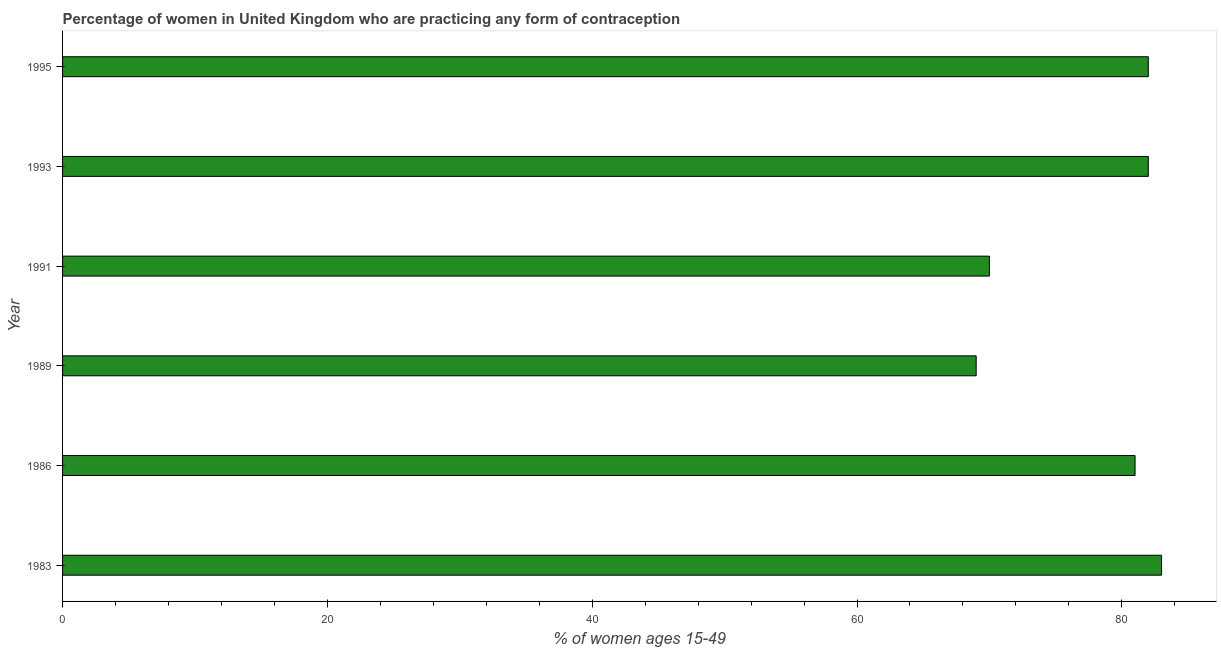Does the graph contain any zero values?
Offer a very short reply. No. What is the title of the graph?
Offer a terse response. Percentage of women in United Kingdom who are practicing any form of contraception. What is the label or title of the X-axis?
Offer a terse response. % of women ages 15-49. What is the label or title of the Y-axis?
Offer a terse response. Year. What is the contraceptive prevalence in 1991?
Give a very brief answer. 70. Across all years, what is the maximum contraceptive prevalence?
Your response must be concise. 83. Across all years, what is the minimum contraceptive prevalence?
Offer a very short reply. 69. In which year was the contraceptive prevalence maximum?
Make the answer very short. 1983. What is the sum of the contraceptive prevalence?
Your answer should be compact. 467. What is the median contraceptive prevalence?
Your answer should be compact. 81.5. What is the ratio of the contraceptive prevalence in 1986 to that in 1993?
Provide a succinct answer. 0.99. Is the contraceptive prevalence in 1983 less than that in 1986?
Ensure brevity in your answer.  No. Is the difference between the contraceptive prevalence in 1993 and 1995 greater than the difference between any two years?
Provide a short and direct response. No. What is the difference between the highest and the lowest contraceptive prevalence?
Your answer should be compact. 14. How many bars are there?
Your answer should be compact. 6. What is the difference between two consecutive major ticks on the X-axis?
Your answer should be compact. 20. Are the values on the major ticks of X-axis written in scientific E-notation?
Provide a short and direct response. No. What is the % of women ages 15-49 of 1983?
Give a very brief answer. 83. What is the % of women ages 15-49 in 1986?
Your answer should be compact. 81. What is the % of women ages 15-49 in 1989?
Your answer should be very brief. 69. What is the % of women ages 15-49 of 1991?
Offer a very short reply. 70. What is the % of women ages 15-49 in 1995?
Offer a terse response. 82. What is the difference between the % of women ages 15-49 in 1983 and 1986?
Offer a very short reply. 2. What is the difference between the % of women ages 15-49 in 1983 and 1993?
Make the answer very short. 1. What is the difference between the % of women ages 15-49 in 1983 and 1995?
Offer a terse response. 1. What is the difference between the % of women ages 15-49 in 1986 and 1991?
Provide a succinct answer. 11. What is the difference between the % of women ages 15-49 in 1986 and 1993?
Your answer should be compact. -1. What is the ratio of the % of women ages 15-49 in 1983 to that in 1989?
Ensure brevity in your answer.  1.2. What is the ratio of the % of women ages 15-49 in 1983 to that in 1991?
Offer a terse response. 1.19. What is the ratio of the % of women ages 15-49 in 1983 to that in 1995?
Offer a very short reply. 1.01. What is the ratio of the % of women ages 15-49 in 1986 to that in 1989?
Provide a succinct answer. 1.17. What is the ratio of the % of women ages 15-49 in 1986 to that in 1991?
Provide a succinct answer. 1.16. What is the ratio of the % of women ages 15-49 in 1986 to that in 1995?
Ensure brevity in your answer.  0.99. What is the ratio of the % of women ages 15-49 in 1989 to that in 1991?
Your response must be concise. 0.99. What is the ratio of the % of women ages 15-49 in 1989 to that in 1993?
Offer a very short reply. 0.84. What is the ratio of the % of women ages 15-49 in 1989 to that in 1995?
Offer a very short reply. 0.84. What is the ratio of the % of women ages 15-49 in 1991 to that in 1993?
Your answer should be very brief. 0.85. What is the ratio of the % of women ages 15-49 in 1991 to that in 1995?
Offer a terse response. 0.85. What is the ratio of the % of women ages 15-49 in 1993 to that in 1995?
Keep it short and to the point. 1. 